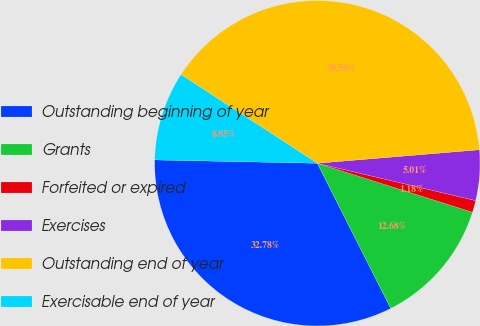Convert chart. <chart><loc_0><loc_0><loc_500><loc_500><pie_chart><fcel>Outstanding beginning of year<fcel>Grants<fcel>Forfeited or expired<fcel>Exercises<fcel>Outstanding end of year<fcel>Exercisable end of year<nl><fcel>32.78%<fcel>12.68%<fcel>1.18%<fcel>5.01%<fcel>39.5%<fcel>8.85%<nl></chart> 